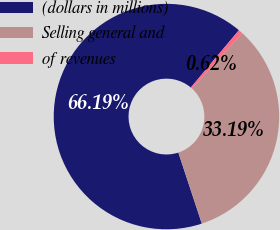Convert chart. <chart><loc_0><loc_0><loc_500><loc_500><pie_chart><fcel>(dollars in millions)<fcel>Selling general and<fcel>of revenues<nl><fcel>66.19%<fcel>33.19%<fcel>0.62%<nl></chart> 